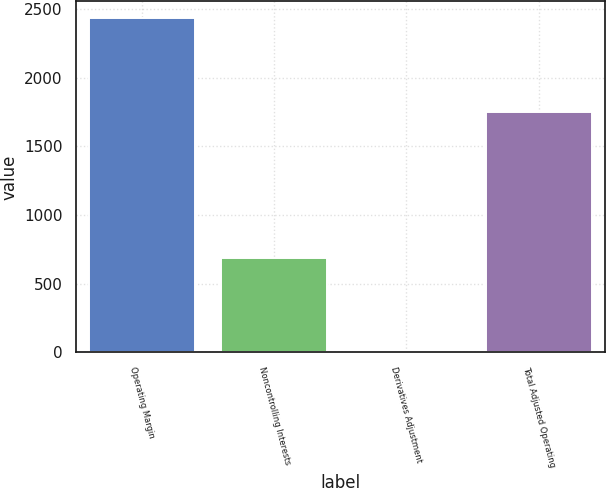Convert chart to OTSL. <chart><loc_0><loc_0><loc_500><loc_500><bar_chart><fcel>Operating Margin<fcel>Noncontrolling Interests<fcel>Derivatives Adjustment<fcel>Total Adjusted Operating<nl><fcel>2433<fcel>689<fcel>9<fcel>1753<nl></chart> 